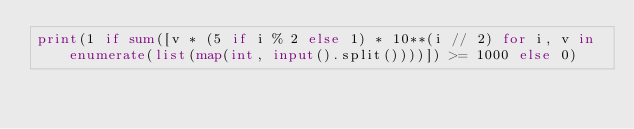<code> <loc_0><loc_0><loc_500><loc_500><_Python_>print(1 if sum([v * (5 if i % 2 else 1) * 10**(i // 2) for i, v in enumerate(list(map(int, input().split())))]) >= 1000 else 0)</code> 